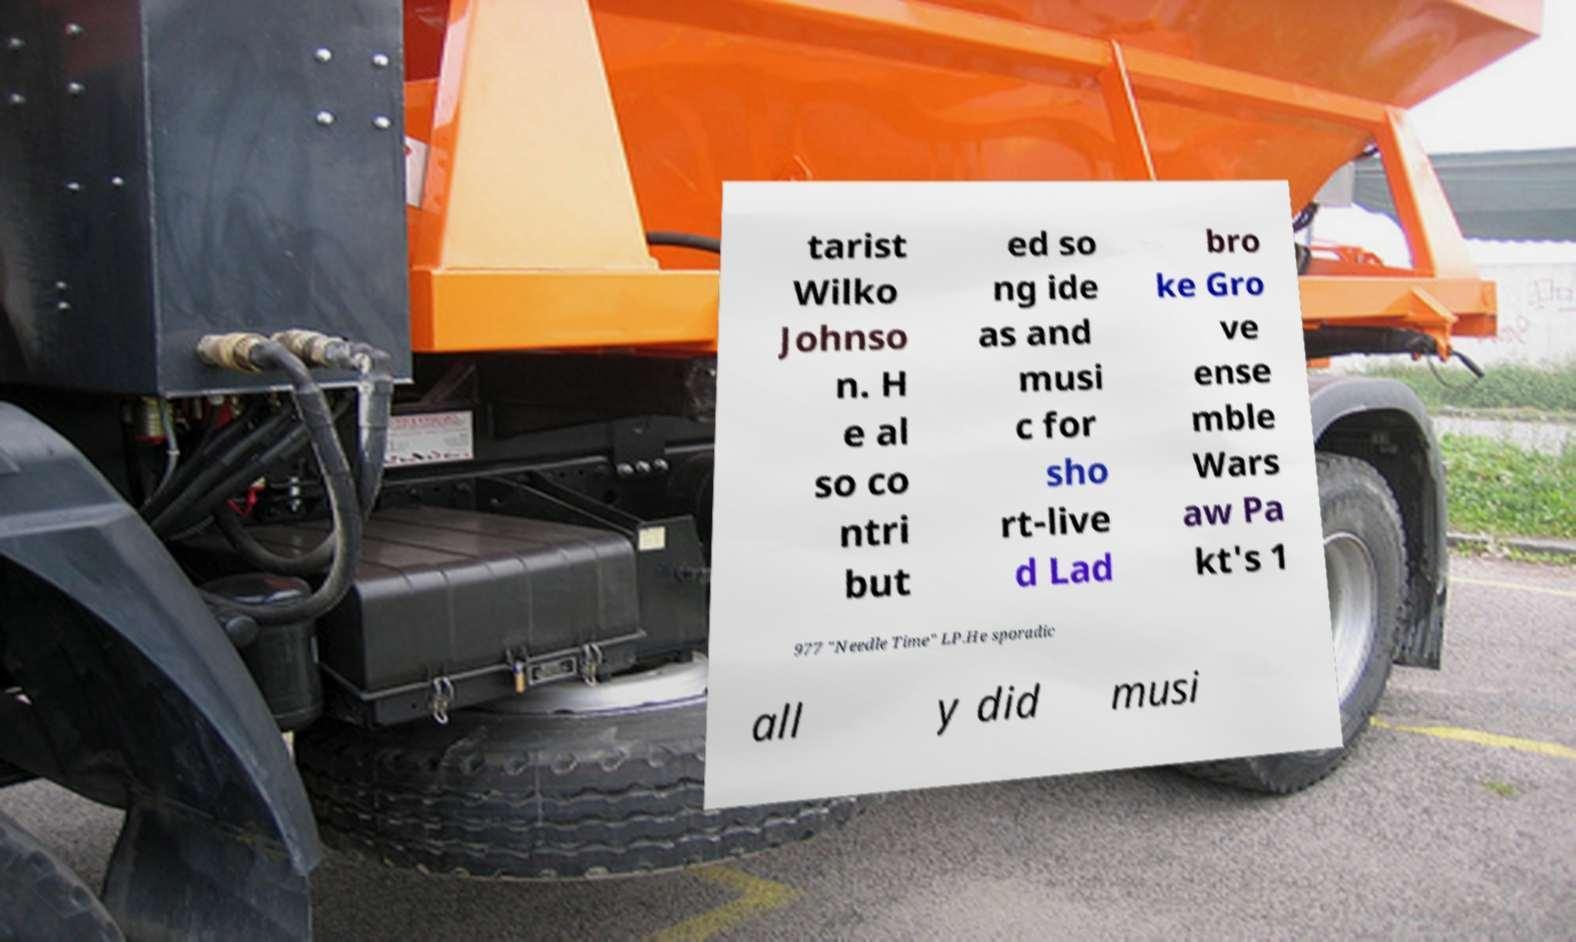For documentation purposes, I need the text within this image transcribed. Could you provide that? tarist Wilko Johnso n. H e al so co ntri but ed so ng ide as and musi c for sho rt-live d Lad bro ke Gro ve ense mble Wars aw Pa kt's 1 977 "Needle Time" LP.He sporadic all y did musi 